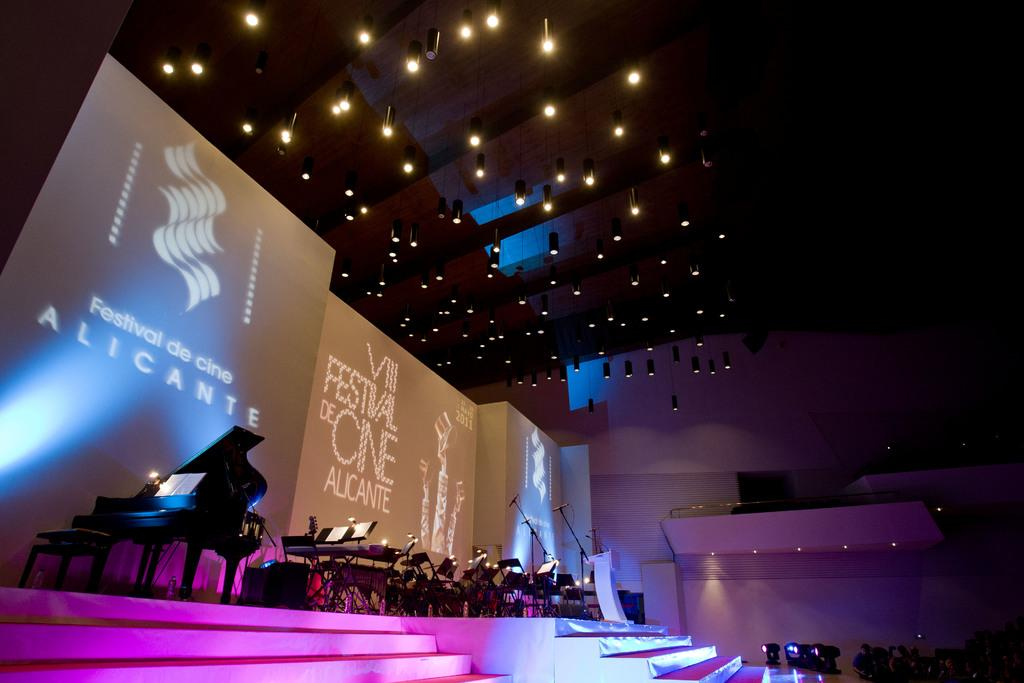What can be seen on the stage in the image? There are musical instruments on the stage. What is located at the back of the stage? There is a banner at the back of the stage. What is positioned at the top of the stage? There are lights at the top of the stage. How does the comb help the musicians on stage? There is no comb present in the image, so it cannot help the musicians on stage. 